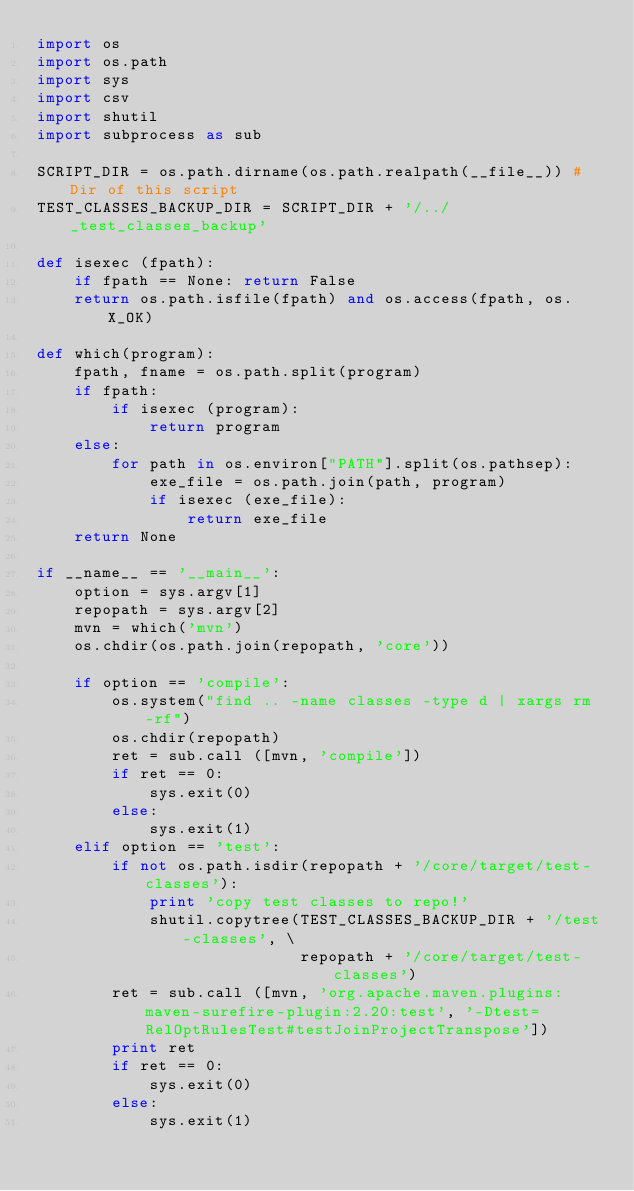<code> <loc_0><loc_0><loc_500><loc_500><_Python_>import os
import os.path
import sys
import csv
import shutil
import subprocess as sub

SCRIPT_DIR = os.path.dirname(os.path.realpath(__file__)) # Dir of this script
TEST_CLASSES_BACKUP_DIR = SCRIPT_DIR + '/../_test_classes_backup'

def isexec (fpath):
    if fpath == None: return False
    return os.path.isfile(fpath) and os.access(fpath, os.X_OK) 

def which(program):
    fpath, fname = os.path.split(program)
    if fpath:
        if isexec (program):
            return program
    else:
        for path in os.environ["PATH"].split(os.pathsep):
            exe_file = os.path.join(path, program)
            if isexec (exe_file):
                return exe_file
    return None

if __name__ == '__main__':
    option = sys.argv[1]
    repopath = sys.argv[2]
    mvn = which('mvn')
    os.chdir(os.path.join(repopath, 'core'))
    
    if option == 'compile':
        os.system("find .. -name classes -type d | xargs rm -rf")
        os.chdir(repopath)
        ret = sub.call ([mvn, 'compile'])
        if ret == 0:
            sys.exit(0)
        else:
            sys.exit(1)
    elif option == 'test':
        if not os.path.isdir(repopath + '/core/target/test-classes'):
            print 'copy test classes to repo!'
            shutil.copytree(TEST_CLASSES_BACKUP_DIR + '/test-classes', \
                            repopath + '/core/target/test-classes')
        ret = sub.call ([mvn, 'org.apache.maven.plugins:maven-surefire-plugin:2.20:test', '-Dtest=RelOptRulesTest#testJoinProjectTranspose'])
        print ret
        if ret == 0:
            sys.exit(0)
        else:
            sys.exit(1)
</code> 